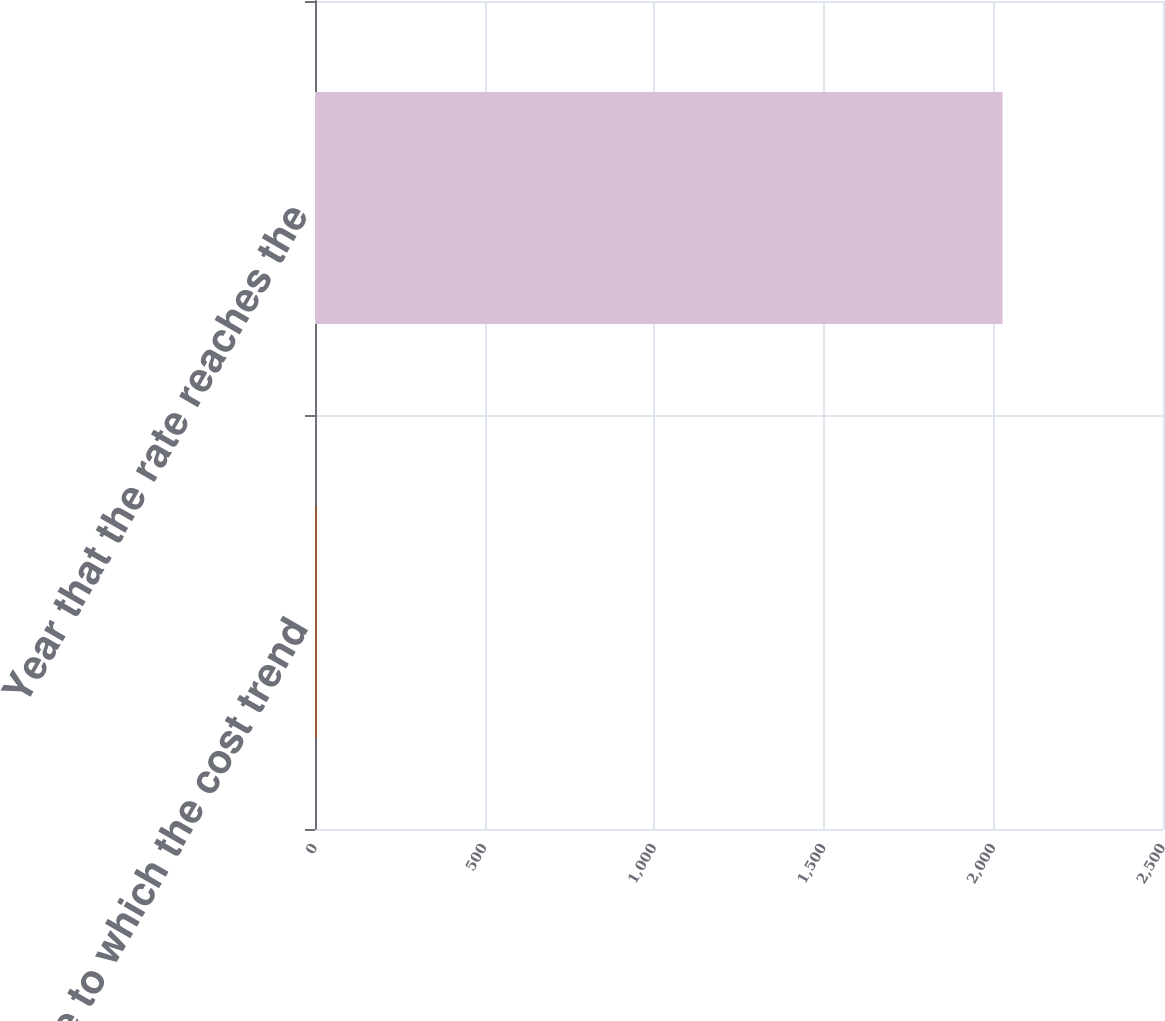Convert chart to OTSL. <chart><loc_0><loc_0><loc_500><loc_500><bar_chart><fcel>Rate to which the cost trend<fcel>Year that the rate reaches the<nl><fcel>5<fcel>2027<nl></chart> 